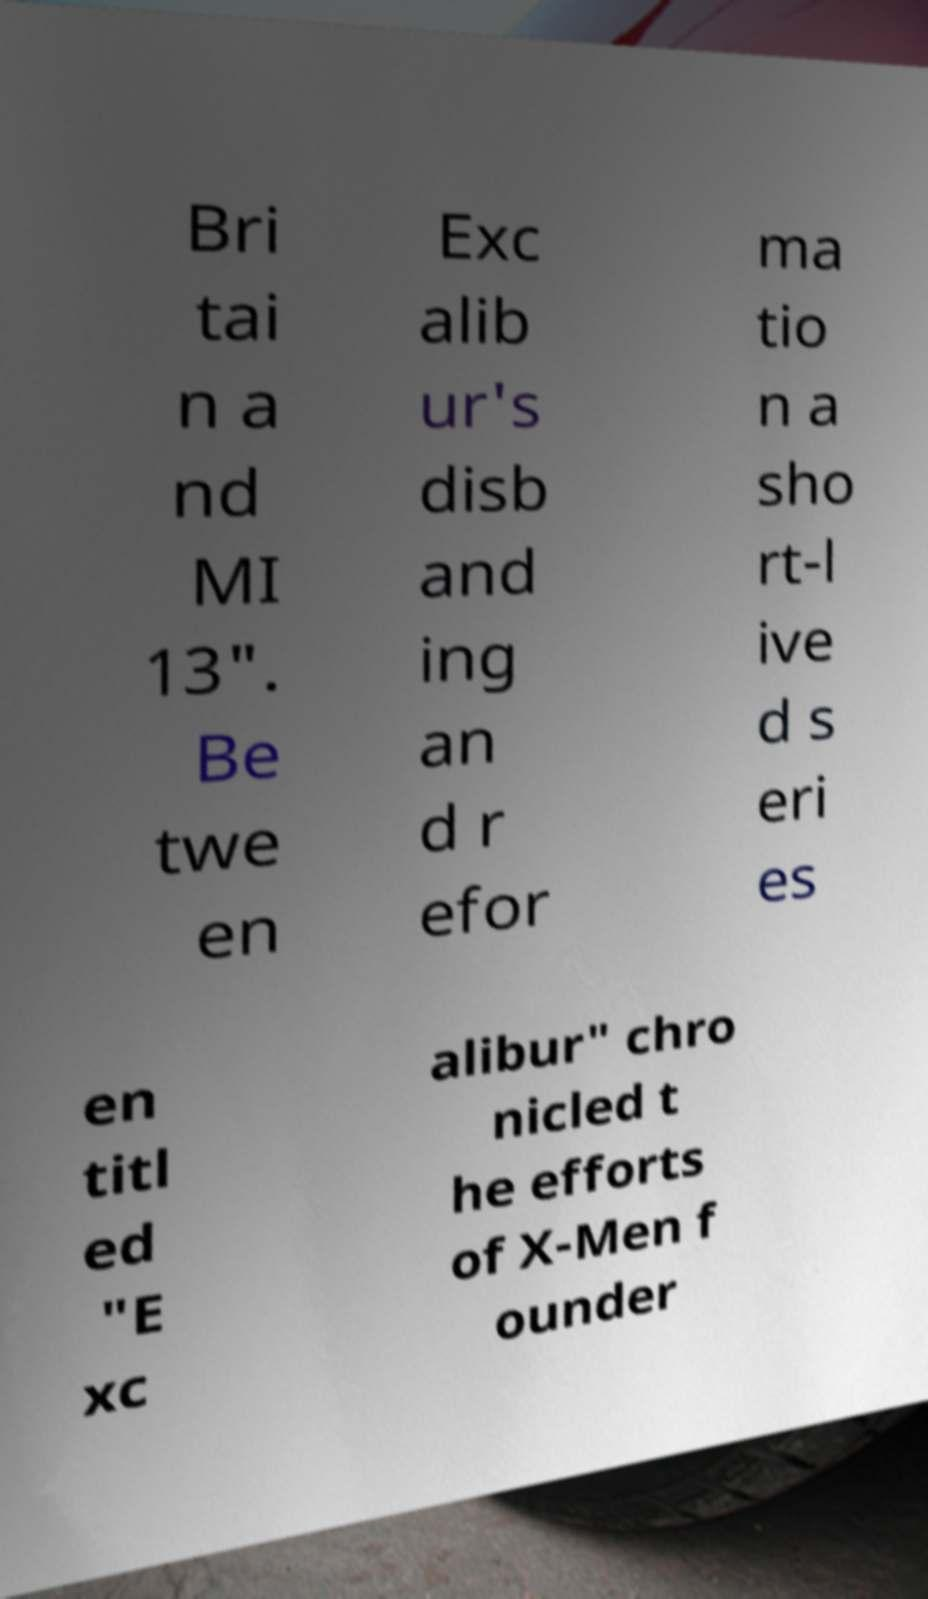There's text embedded in this image that I need extracted. Can you transcribe it verbatim? Bri tai n a nd MI 13". Be twe en Exc alib ur's disb and ing an d r efor ma tio n a sho rt-l ive d s eri es en titl ed "E xc alibur" chro nicled t he efforts of X-Men f ounder 